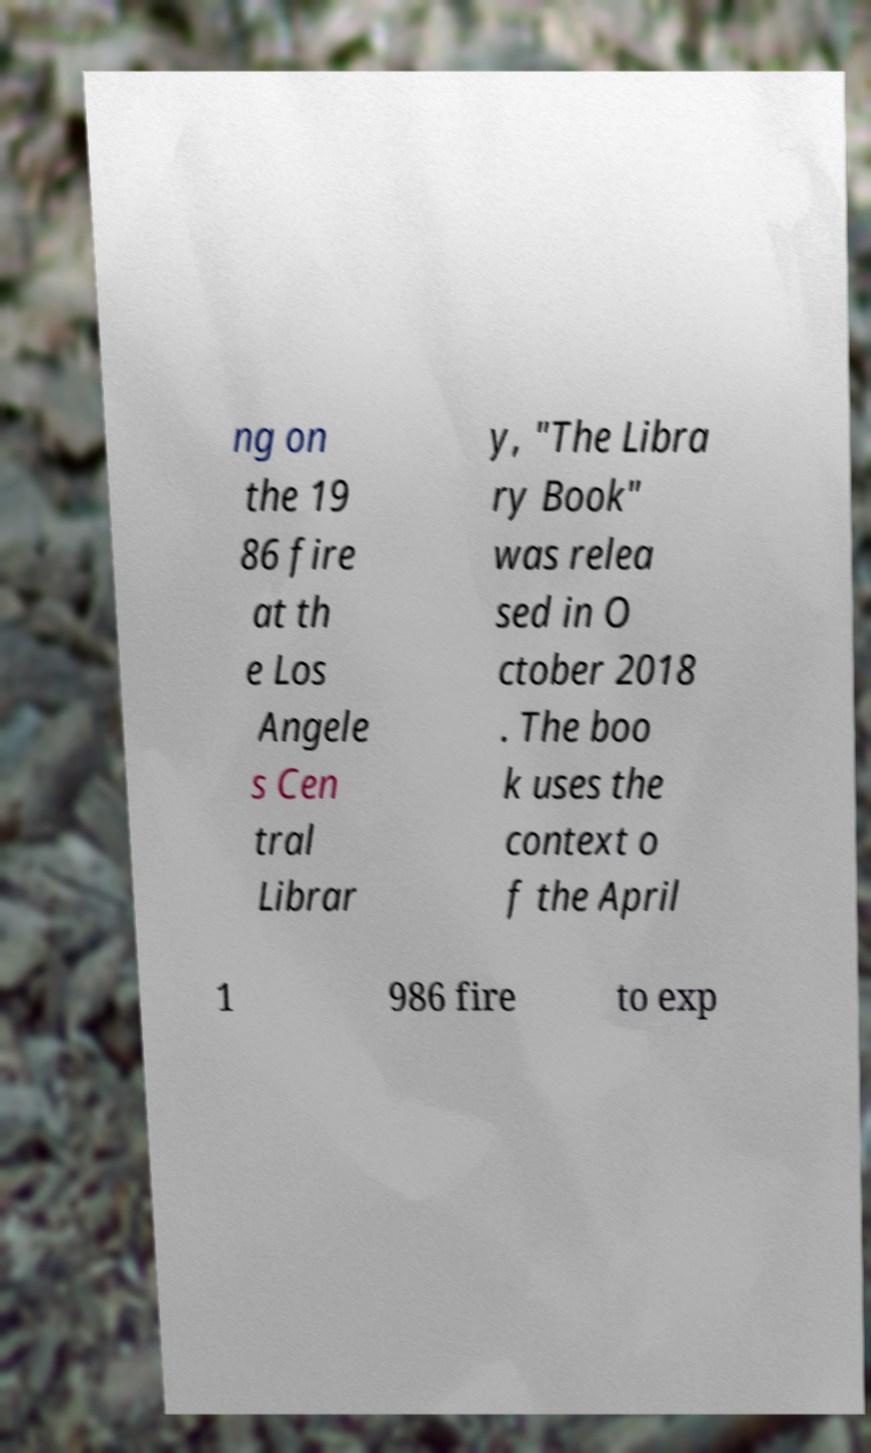For documentation purposes, I need the text within this image transcribed. Could you provide that? ng on the 19 86 fire at th e Los Angele s Cen tral Librar y, "The Libra ry Book" was relea sed in O ctober 2018 . The boo k uses the context o f the April 1 986 fire to exp 